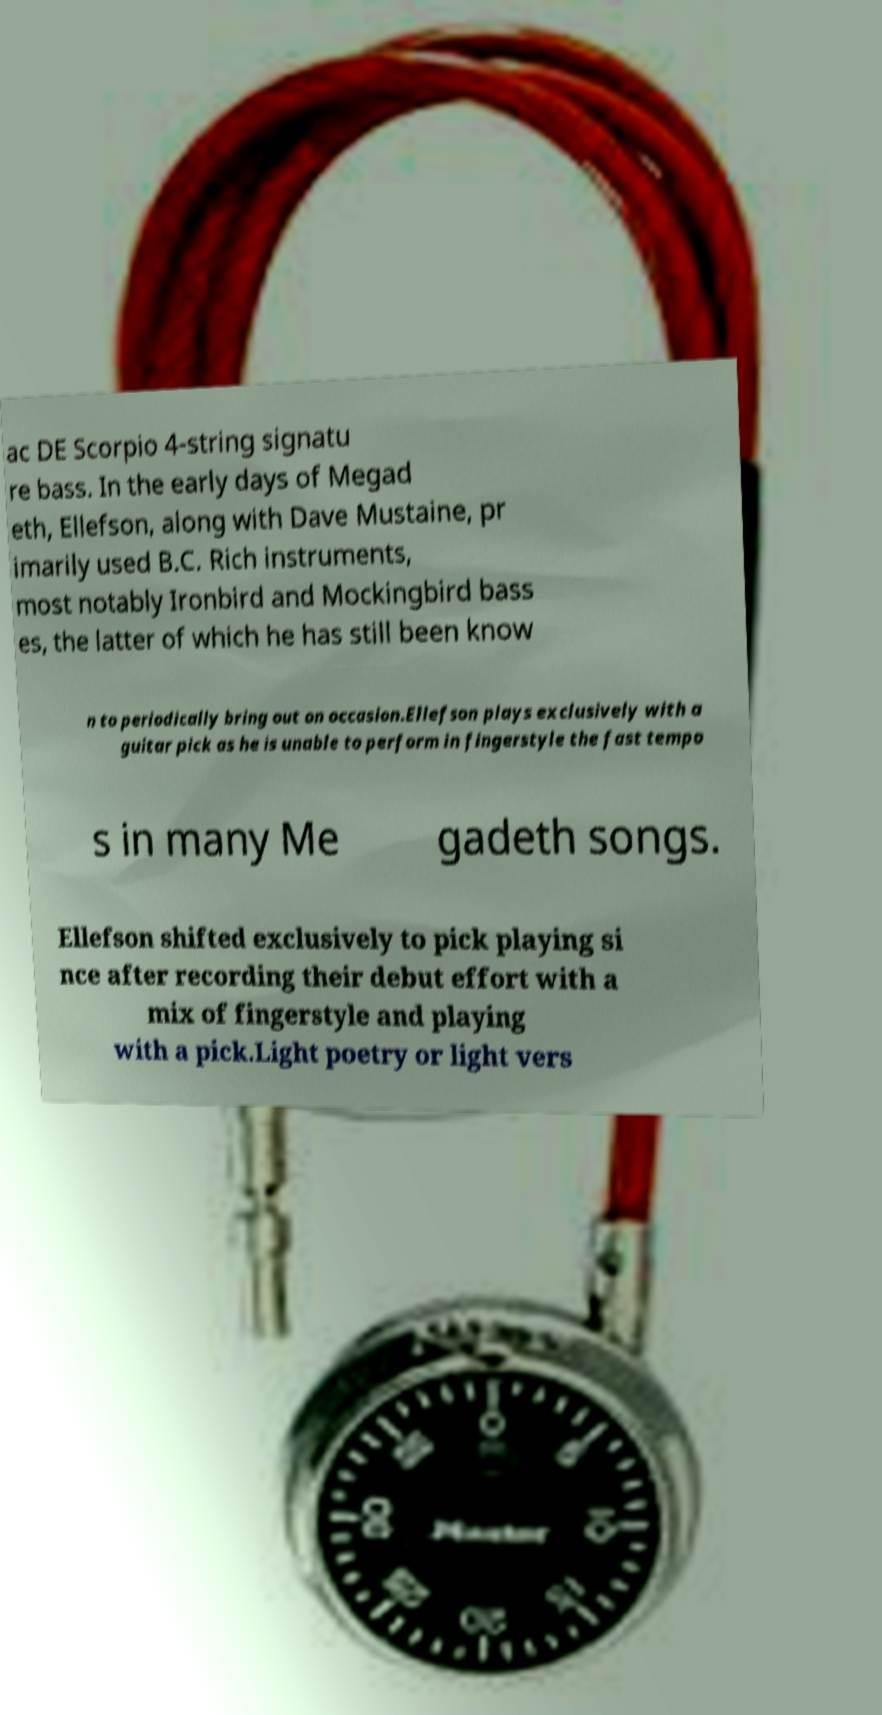Could you assist in decoding the text presented in this image and type it out clearly? ac DE Scorpio 4-string signatu re bass. In the early days of Megad eth, Ellefson, along with Dave Mustaine, pr imarily used B.C. Rich instruments, most notably Ironbird and Mockingbird bass es, the latter of which he has still been know n to periodically bring out on occasion.Ellefson plays exclusively with a guitar pick as he is unable to perform in fingerstyle the fast tempo s in many Me gadeth songs. Ellefson shifted exclusively to pick playing si nce after recording their debut effort with a mix of fingerstyle and playing with a pick.Light poetry or light vers 